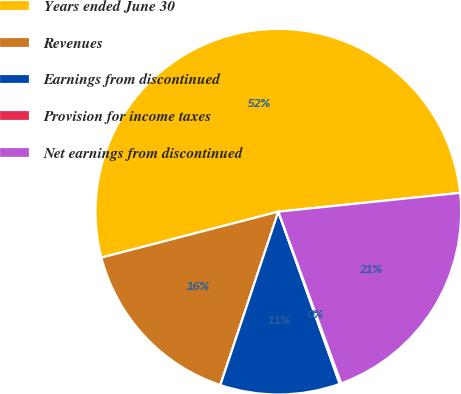<chart> <loc_0><loc_0><loc_500><loc_500><pie_chart><fcel>Years ended June 30<fcel>Revenues<fcel>Earnings from discontinued<fcel>Provision for income taxes<fcel>Net earnings from discontinued<nl><fcel>52.41%<fcel>15.82%<fcel>10.59%<fcel>0.14%<fcel>21.05%<nl></chart> 